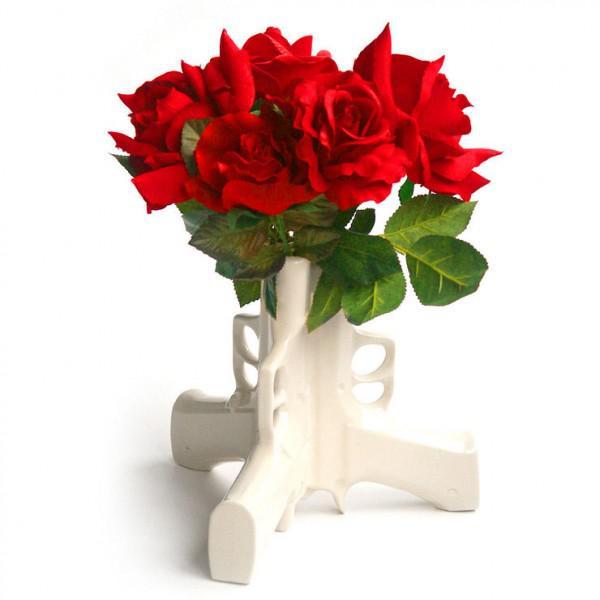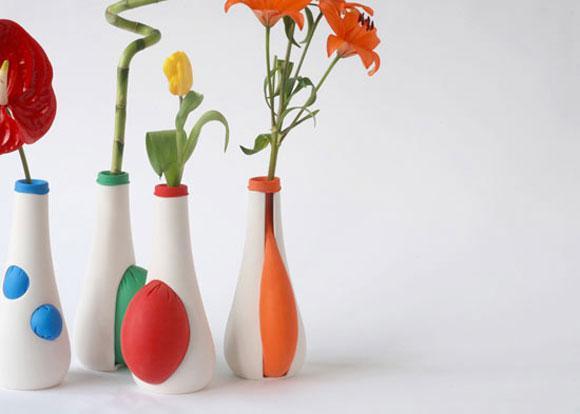The first image is the image on the left, the second image is the image on the right. Analyze the images presented: Is the assertion "The right image contains at least two flower vases." valid? Answer yes or no. Yes. The first image is the image on the left, the second image is the image on the right. For the images shown, is this caption "there is a vase with at least one tulip in it" true? Answer yes or no. Yes. 